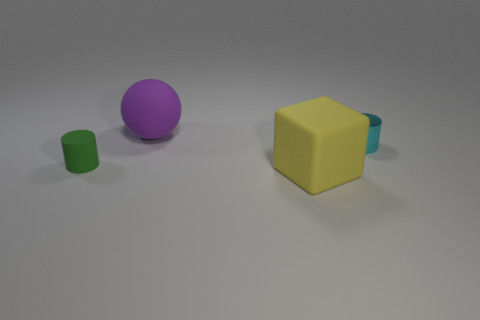Add 1 big metallic balls. How many objects exist? 5 Subtract all balls. How many objects are left? 3 Subtract all big yellow cylinders. Subtract all purple balls. How many objects are left? 3 Add 3 yellow cubes. How many yellow cubes are left? 4 Add 4 large yellow matte blocks. How many large yellow matte blocks exist? 5 Subtract 0 yellow cylinders. How many objects are left? 4 